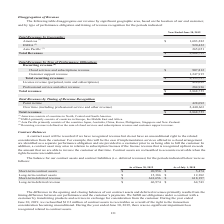According to Opentext Corporation's financial document, What does this table represent? balance for our contract assets and contract liabilities (i.e. deferred revenues) for the periods indicated. The document states: "The balance for our contract assets and contract liabilities (i.e. deferred revenues) for the periods indicated below were as follows:..." Also, When was $19.2 million of contract assets to receivables as a result of the right to the transaction consideration becoming unconditional reclassified? year ended June 30, 2019. The document states: "Year Ended June 30, 2019 Year Ended June 30, 2019..." Also, When will a contract asset be recorded? if we have recognized revenue but do not have an unconditional right to the related consideration from the customer. The document states: "A contract asset will be recorded if we have recognized revenue but do not have an unconditional right to the related consideration from the customer...." Also, can you calculate:  What is the total contract assets as of June 30, 2019?  Based on the calculation: 20,956 +15,386, the result is 36342 (in thousands). This is based on the information: "9 As of July 1, 2018 Short-term contract assets $ 20,956 $ 5,474 Long-term contract assets $ 15,386 $ 12,382 Short-term deferred revenue $ 641,656 $ 618,197 sets $ 20,956 $ 5,474 Long-term contract as..." The key data points involved are: 15,386, 20,956. Also, can you calculate: What is the total deferred revenue as of June 30, 2019? Based on the calculation: 641,656+46,974, the result is 688630 (in thousands). This is based on the information: "s $ 15,386 $ 12,382 Short-term deferred revenue $ 641,656 $ 618,197 Long-term deferred revenue $ 46,974 $ 64,743 $ 641,656 $ 618,197 Long-term deferred revenue $ 46,974 $ 64,743..." The key data points involved are: 46,974, 641,656. Also, can you calculate: What is the total revenue and assets as of June 30, 2019? Based on the calculation: 20,956+15,386+641,656+46,974, the result is 724972 (in thousands). This is based on the information: "s $ 15,386 $ 12,382 Short-term deferred revenue $ 641,656 $ 618,197 Long-term deferred revenue $ 46,974 $ 64,743 9 As of July 1, 2018 Short-term contract assets $ 20,956 $ 5,474 Long-term contract ass..." The key data points involved are: 15,386, 20,956, 46,974. 